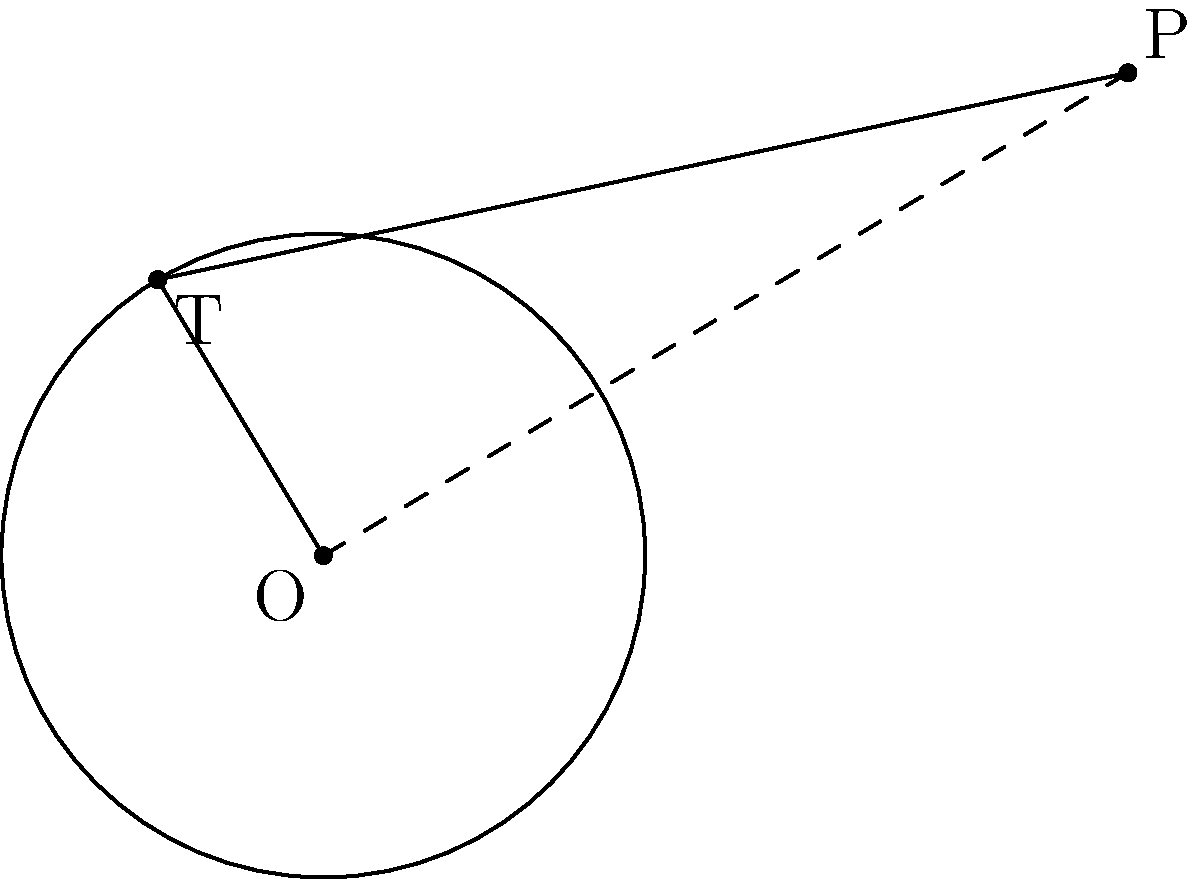In the diagram, $O$ is the center of a circle with radius 2 units. Point $P$ is external to the circle at coordinates (5, 3). If $T$ is the point where a tangent line from $P$ touches the circle, calculate the length of $\overline{PT}$ to two decimal places. Let's approach this step-by-step:

1) First, we need to find the distance between $O$ and $P$. We can do this using the distance formula:

   $$OP = \sqrt{(5-0)^2 + (3-0)^2} = \sqrt{25 + 9} = \sqrt{34}$$

2) Now, we can use the Pythagorean theorem. In the right triangle $OPT$:

   $$OP^2 = OT^2 + PT^2$$

3) We know that $OT$ is the radius of the circle, which is 2 units. Let's substitute what we know:

   $$34 = 2^2 + PT^2$$

4) Simplify:

   $$34 = 4 + PT^2$$

5) Subtract 4 from both sides:

   $$30 = PT^2$$

6) Take the square root of both sides:

   $$PT = \sqrt{30} \approx 5.48$$

7) Rounding to two decimal places:

   $$PT \approx 5.48$$
Answer: 5.48 units 